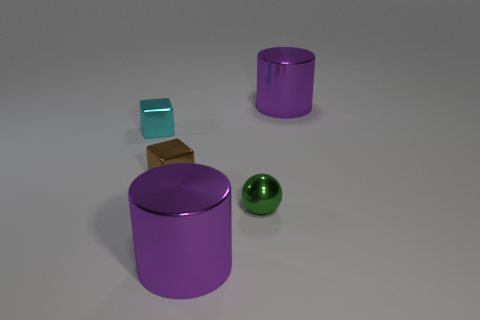Add 2 small brown things. How many objects exist? 7 Subtract all spheres. How many objects are left? 4 Add 5 green shiny spheres. How many green shiny spheres are left? 6 Add 4 metallic blocks. How many metallic blocks exist? 6 Subtract 0 gray balls. How many objects are left? 5 Subtract all purple things. Subtract all brown shiny things. How many objects are left? 2 